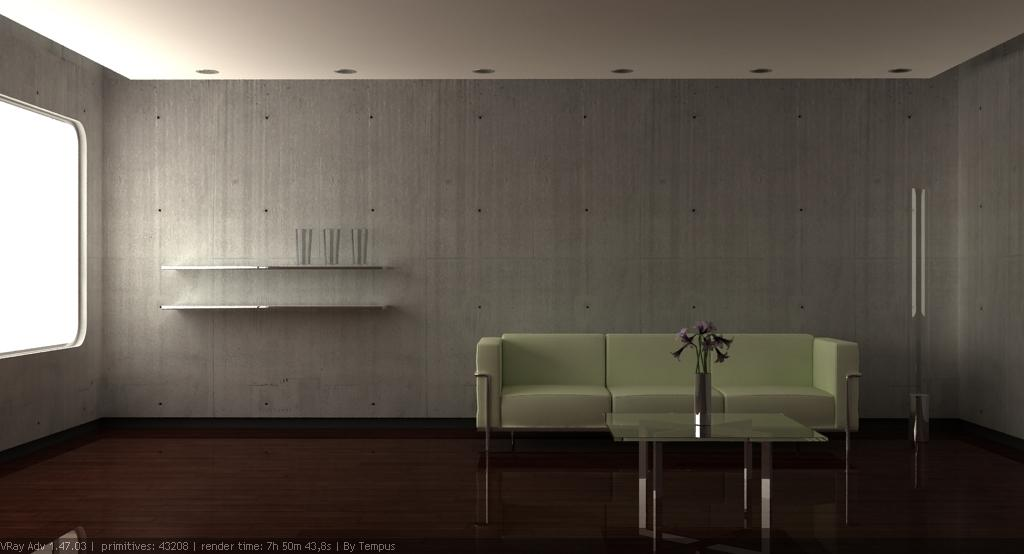What type of furniture is present in the image? There is a sofa in the image. What other piece of furniture can be seen in the image? There is a glass table in the image. What is placed on the glass table? There is a plant on the glass table. What architectural feature is visible in the image? There is a window on the side in the image. What disease is the plant on the glass table suffering from in the image? There is no indication of any disease in the image; the plant appears to be healthy. What type of punishment is being administered to the sofa in the image? There is no punishment being administered to the sofa in the image; it is simply a piece of furniture. 